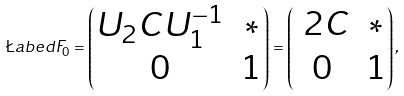<formula> <loc_0><loc_0><loc_500><loc_500>\L a b e d F _ { 0 } = \left ( \begin{matrix} U _ { 2 } C U _ { 1 } ^ { - 1 } & \ast \\ 0 & 1 \end{matrix} \right ) = \left ( \begin{matrix} \ 2 C & \ast \\ 0 & 1 \end{matrix} \right ) ,</formula> 